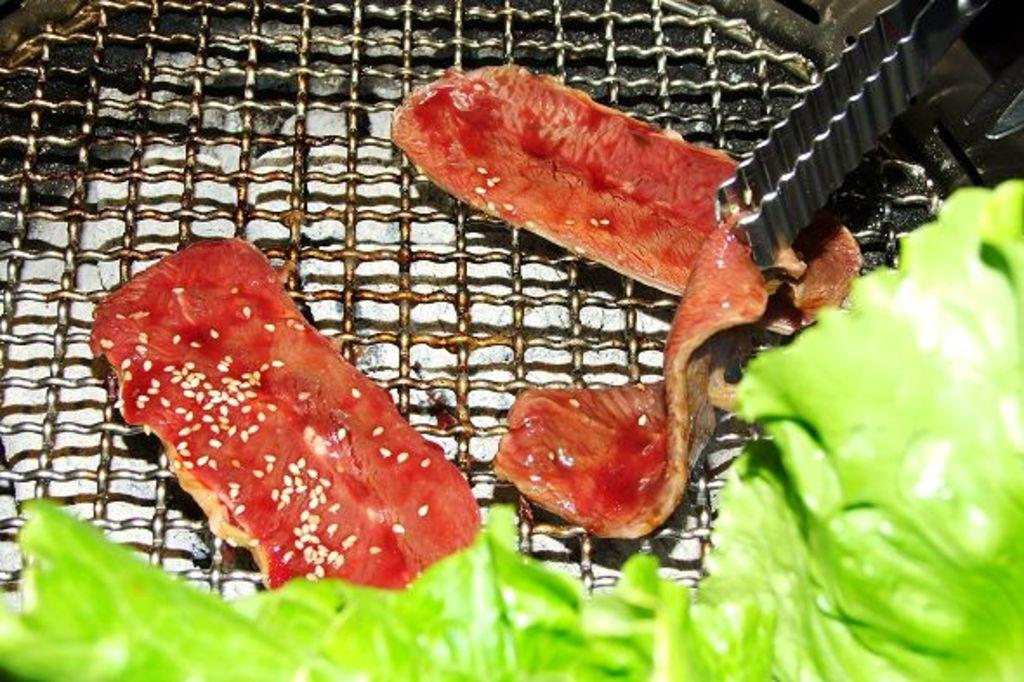What is being cooked on the grill in the image? The image shows food on the grill. How does the elbow help in the cooking process in the image? There is no elbow present in the image, so it cannot help in the cooking process. 